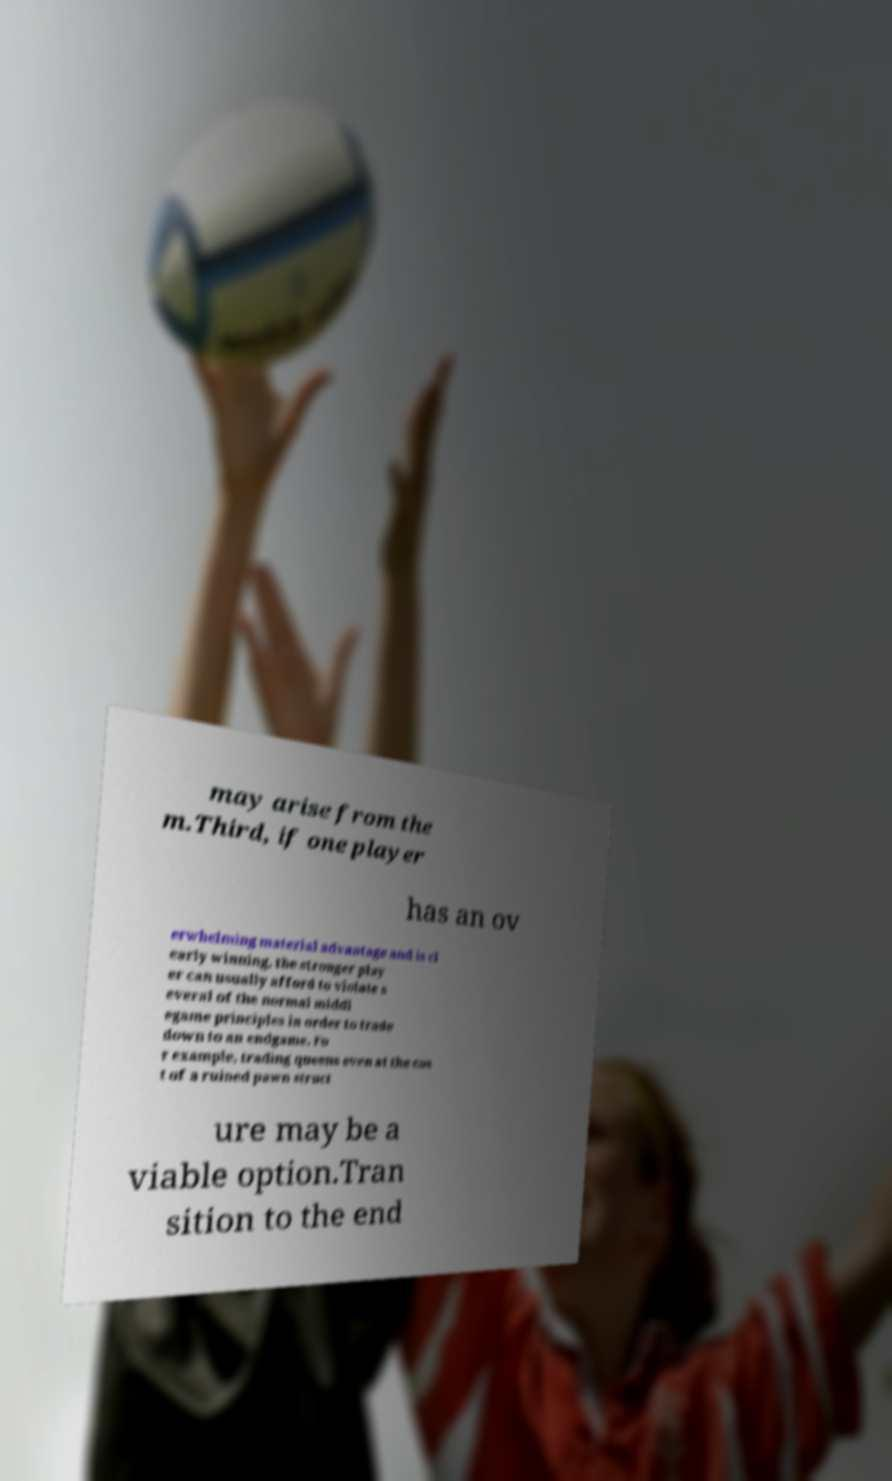I need the written content from this picture converted into text. Can you do that? may arise from the m.Third, if one player has an ov erwhelming material advantage and is cl early winning, the stronger play er can usually afford to violate s everal of the normal middl egame principles in order to trade down to an endgame. Fo r example, trading queens even at the cos t of a ruined pawn struct ure may be a viable option.Tran sition to the end 